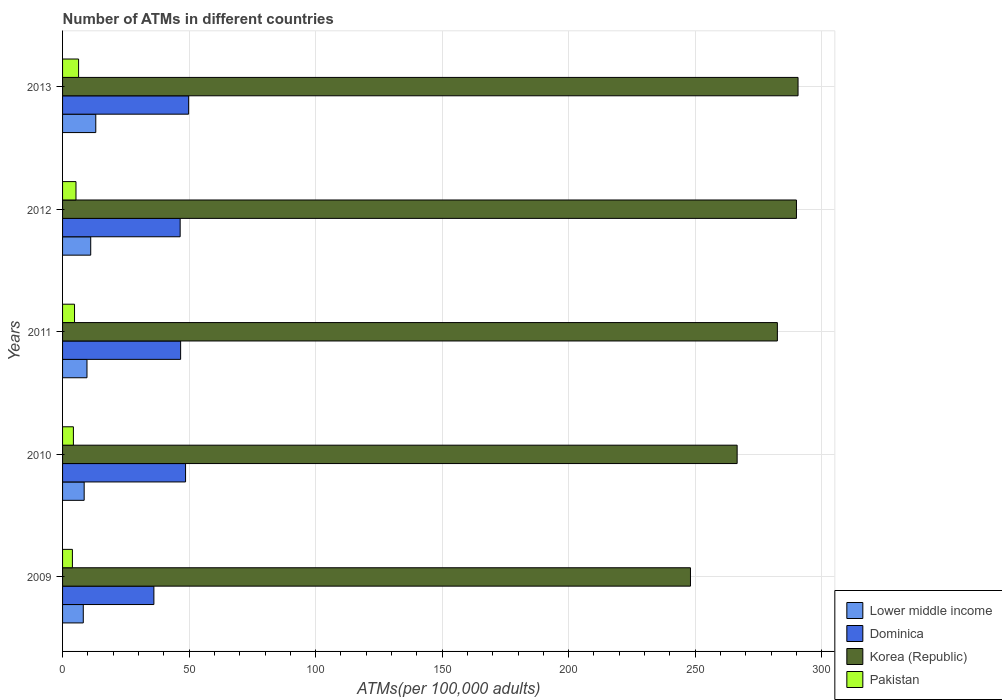How many different coloured bars are there?
Your answer should be compact. 4. Are the number of bars on each tick of the Y-axis equal?
Offer a very short reply. Yes. How many bars are there on the 2nd tick from the bottom?
Keep it short and to the point. 4. In how many cases, is the number of bars for a given year not equal to the number of legend labels?
Keep it short and to the point. 0. What is the number of ATMs in Pakistan in 2009?
Keep it short and to the point. 3.89. Across all years, what is the maximum number of ATMs in Dominica?
Your answer should be compact. 49.82. Across all years, what is the minimum number of ATMs in Lower middle income?
Your answer should be compact. 8.19. In which year was the number of ATMs in Pakistan minimum?
Ensure brevity in your answer.  2009. What is the total number of ATMs in Korea (Republic) in the graph?
Your answer should be very brief. 1377.92. What is the difference between the number of ATMs in Dominica in 2009 and that in 2013?
Offer a terse response. -13.73. What is the difference between the number of ATMs in Pakistan in 2010 and the number of ATMs in Korea (Republic) in 2012?
Keep it short and to the point. -285.75. What is the average number of ATMs in Korea (Republic) per year?
Your answer should be very brief. 275.58. In the year 2012, what is the difference between the number of ATMs in Korea (Republic) and number of ATMs in Dominica?
Provide a succinct answer. 243.56. What is the ratio of the number of ATMs in Dominica in 2011 to that in 2013?
Your answer should be very brief. 0.94. What is the difference between the highest and the second highest number of ATMs in Lower middle income?
Give a very brief answer. 2. What is the difference between the highest and the lowest number of ATMs in Korea (Republic)?
Keep it short and to the point. 42.51. What does the 4th bar from the top in 2012 represents?
Provide a succinct answer. Lower middle income. What does the 4th bar from the bottom in 2010 represents?
Keep it short and to the point. Pakistan. Is it the case that in every year, the sum of the number of ATMs in Korea (Republic) and number of ATMs in Lower middle income is greater than the number of ATMs in Dominica?
Provide a short and direct response. Yes. Are all the bars in the graph horizontal?
Make the answer very short. Yes. Does the graph contain any zero values?
Your response must be concise. No. Where does the legend appear in the graph?
Keep it short and to the point. Bottom right. What is the title of the graph?
Provide a short and direct response. Number of ATMs in different countries. What is the label or title of the X-axis?
Provide a short and direct response. ATMs(per 100,0 adults). What is the ATMs(per 100,000 adults) in Lower middle income in 2009?
Your answer should be compact. 8.19. What is the ATMs(per 100,000 adults) in Dominica in 2009?
Provide a succinct answer. 36.09. What is the ATMs(per 100,000 adults) of Korea (Republic) in 2009?
Provide a succinct answer. 248.15. What is the ATMs(per 100,000 adults) of Pakistan in 2009?
Your answer should be very brief. 3.89. What is the ATMs(per 100,000 adults) in Lower middle income in 2010?
Your answer should be compact. 8.54. What is the ATMs(per 100,000 adults) in Dominica in 2010?
Your answer should be very brief. 48.61. What is the ATMs(per 100,000 adults) of Korea (Republic) in 2010?
Provide a succinct answer. 266.59. What is the ATMs(per 100,000 adults) in Pakistan in 2010?
Ensure brevity in your answer.  4.28. What is the ATMs(per 100,000 adults) of Lower middle income in 2011?
Ensure brevity in your answer.  9.65. What is the ATMs(per 100,000 adults) in Dominica in 2011?
Your response must be concise. 46.65. What is the ATMs(per 100,000 adults) in Korea (Republic) in 2011?
Offer a terse response. 282.49. What is the ATMs(per 100,000 adults) in Pakistan in 2011?
Offer a very short reply. 4.73. What is the ATMs(per 100,000 adults) in Lower middle income in 2012?
Offer a terse response. 11.13. What is the ATMs(per 100,000 adults) in Dominica in 2012?
Your response must be concise. 46.47. What is the ATMs(per 100,000 adults) in Korea (Republic) in 2012?
Provide a succinct answer. 290.03. What is the ATMs(per 100,000 adults) of Pakistan in 2012?
Your answer should be compact. 5.31. What is the ATMs(per 100,000 adults) of Lower middle income in 2013?
Your response must be concise. 13.13. What is the ATMs(per 100,000 adults) in Dominica in 2013?
Ensure brevity in your answer.  49.82. What is the ATMs(per 100,000 adults) of Korea (Republic) in 2013?
Your answer should be compact. 290.66. What is the ATMs(per 100,000 adults) of Pakistan in 2013?
Keep it short and to the point. 6.33. Across all years, what is the maximum ATMs(per 100,000 adults) in Lower middle income?
Ensure brevity in your answer.  13.13. Across all years, what is the maximum ATMs(per 100,000 adults) of Dominica?
Your answer should be very brief. 49.82. Across all years, what is the maximum ATMs(per 100,000 adults) in Korea (Republic)?
Provide a succinct answer. 290.66. Across all years, what is the maximum ATMs(per 100,000 adults) of Pakistan?
Make the answer very short. 6.33. Across all years, what is the minimum ATMs(per 100,000 adults) of Lower middle income?
Ensure brevity in your answer.  8.19. Across all years, what is the minimum ATMs(per 100,000 adults) in Dominica?
Your response must be concise. 36.09. Across all years, what is the minimum ATMs(per 100,000 adults) of Korea (Republic)?
Offer a terse response. 248.15. Across all years, what is the minimum ATMs(per 100,000 adults) in Pakistan?
Provide a succinct answer. 3.89. What is the total ATMs(per 100,000 adults) in Lower middle income in the graph?
Offer a very short reply. 50.63. What is the total ATMs(per 100,000 adults) in Dominica in the graph?
Provide a succinct answer. 227.65. What is the total ATMs(per 100,000 adults) in Korea (Republic) in the graph?
Ensure brevity in your answer.  1377.92. What is the total ATMs(per 100,000 adults) of Pakistan in the graph?
Provide a short and direct response. 24.54. What is the difference between the ATMs(per 100,000 adults) in Lower middle income in 2009 and that in 2010?
Provide a short and direct response. -0.35. What is the difference between the ATMs(per 100,000 adults) in Dominica in 2009 and that in 2010?
Your answer should be very brief. -12.52. What is the difference between the ATMs(per 100,000 adults) in Korea (Republic) in 2009 and that in 2010?
Ensure brevity in your answer.  -18.45. What is the difference between the ATMs(per 100,000 adults) in Pakistan in 2009 and that in 2010?
Your answer should be very brief. -0.39. What is the difference between the ATMs(per 100,000 adults) in Lower middle income in 2009 and that in 2011?
Keep it short and to the point. -1.46. What is the difference between the ATMs(per 100,000 adults) in Dominica in 2009 and that in 2011?
Your answer should be compact. -10.56. What is the difference between the ATMs(per 100,000 adults) of Korea (Republic) in 2009 and that in 2011?
Make the answer very short. -34.34. What is the difference between the ATMs(per 100,000 adults) in Pakistan in 2009 and that in 2011?
Your answer should be compact. -0.84. What is the difference between the ATMs(per 100,000 adults) in Lower middle income in 2009 and that in 2012?
Your response must be concise. -2.94. What is the difference between the ATMs(per 100,000 adults) of Dominica in 2009 and that in 2012?
Provide a succinct answer. -10.38. What is the difference between the ATMs(per 100,000 adults) in Korea (Republic) in 2009 and that in 2012?
Ensure brevity in your answer.  -41.88. What is the difference between the ATMs(per 100,000 adults) in Pakistan in 2009 and that in 2012?
Give a very brief answer. -1.41. What is the difference between the ATMs(per 100,000 adults) in Lower middle income in 2009 and that in 2013?
Your response must be concise. -4.94. What is the difference between the ATMs(per 100,000 adults) of Dominica in 2009 and that in 2013?
Offer a terse response. -13.73. What is the difference between the ATMs(per 100,000 adults) in Korea (Republic) in 2009 and that in 2013?
Provide a succinct answer. -42.51. What is the difference between the ATMs(per 100,000 adults) in Pakistan in 2009 and that in 2013?
Offer a terse response. -2.44. What is the difference between the ATMs(per 100,000 adults) in Lower middle income in 2010 and that in 2011?
Offer a terse response. -1.11. What is the difference between the ATMs(per 100,000 adults) of Dominica in 2010 and that in 2011?
Ensure brevity in your answer.  1.95. What is the difference between the ATMs(per 100,000 adults) of Korea (Republic) in 2010 and that in 2011?
Give a very brief answer. -15.9. What is the difference between the ATMs(per 100,000 adults) in Pakistan in 2010 and that in 2011?
Your answer should be compact. -0.45. What is the difference between the ATMs(per 100,000 adults) in Lower middle income in 2010 and that in 2012?
Make the answer very short. -2.59. What is the difference between the ATMs(per 100,000 adults) in Dominica in 2010 and that in 2012?
Offer a terse response. 2.14. What is the difference between the ATMs(per 100,000 adults) of Korea (Republic) in 2010 and that in 2012?
Make the answer very short. -23.44. What is the difference between the ATMs(per 100,000 adults) in Pakistan in 2010 and that in 2012?
Your response must be concise. -1.02. What is the difference between the ATMs(per 100,000 adults) of Lower middle income in 2010 and that in 2013?
Provide a succinct answer. -4.59. What is the difference between the ATMs(per 100,000 adults) in Dominica in 2010 and that in 2013?
Provide a short and direct response. -1.22. What is the difference between the ATMs(per 100,000 adults) of Korea (Republic) in 2010 and that in 2013?
Offer a very short reply. -24.07. What is the difference between the ATMs(per 100,000 adults) of Pakistan in 2010 and that in 2013?
Provide a succinct answer. -2.05. What is the difference between the ATMs(per 100,000 adults) of Lower middle income in 2011 and that in 2012?
Your answer should be compact. -1.48. What is the difference between the ATMs(per 100,000 adults) of Dominica in 2011 and that in 2012?
Make the answer very short. 0.18. What is the difference between the ATMs(per 100,000 adults) of Korea (Republic) in 2011 and that in 2012?
Your response must be concise. -7.54. What is the difference between the ATMs(per 100,000 adults) of Pakistan in 2011 and that in 2012?
Keep it short and to the point. -0.58. What is the difference between the ATMs(per 100,000 adults) in Lower middle income in 2011 and that in 2013?
Keep it short and to the point. -3.47. What is the difference between the ATMs(per 100,000 adults) of Dominica in 2011 and that in 2013?
Give a very brief answer. -3.17. What is the difference between the ATMs(per 100,000 adults) of Korea (Republic) in 2011 and that in 2013?
Your response must be concise. -8.17. What is the difference between the ATMs(per 100,000 adults) of Pakistan in 2011 and that in 2013?
Your answer should be very brief. -1.61. What is the difference between the ATMs(per 100,000 adults) of Lower middle income in 2012 and that in 2013?
Keep it short and to the point. -2. What is the difference between the ATMs(per 100,000 adults) in Dominica in 2012 and that in 2013?
Keep it short and to the point. -3.35. What is the difference between the ATMs(per 100,000 adults) in Korea (Republic) in 2012 and that in 2013?
Your response must be concise. -0.63. What is the difference between the ATMs(per 100,000 adults) of Pakistan in 2012 and that in 2013?
Keep it short and to the point. -1.03. What is the difference between the ATMs(per 100,000 adults) in Lower middle income in 2009 and the ATMs(per 100,000 adults) in Dominica in 2010?
Give a very brief answer. -40.42. What is the difference between the ATMs(per 100,000 adults) of Lower middle income in 2009 and the ATMs(per 100,000 adults) of Korea (Republic) in 2010?
Your response must be concise. -258.4. What is the difference between the ATMs(per 100,000 adults) of Lower middle income in 2009 and the ATMs(per 100,000 adults) of Pakistan in 2010?
Give a very brief answer. 3.91. What is the difference between the ATMs(per 100,000 adults) of Dominica in 2009 and the ATMs(per 100,000 adults) of Korea (Republic) in 2010?
Provide a short and direct response. -230.5. What is the difference between the ATMs(per 100,000 adults) in Dominica in 2009 and the ATMs(per 100,000 adults) in Pakistan in 2010?
Keep it short and to the point. 31.81. What is the difference between the ATMs(per 100,000 adults) of Korea (Republic) in 2009 and the ATMs(per 100,000 adults) of Pakistan in 2010?
Provide a succinct answer. 243.87. What is the difference between the ATMs(per 100,000 adults) in Lower middle income in 2009 and the ATMs(per 100,000 adults) in Dominica in 2011?
Offer a very short reply. -38.47. What is the difference between the ATMs(per 100,000 adults) of Lower middle income in 2009 and the ATMs(per 100,000 adults) of Korea (Republic) in 2011?
Keep it short and to the point. -274.3. What is the difference between the ATMs(per 100,000 adults) of Lower middle income in 2009 and the ATMs(per 100,000 adults) of Pakistan in 2011?
Your answer should be very brief. 3.46. What is the difference between the ATMs(per 100,000 adults) of Dominica in 2009 and the ATMs(per 100,000 adults) of Korea (Republic) in 2011?
Your response must be concise. -246.4. What is the difference between the ATMs(per 100,000 adults) in Dominica in 2009 and the ATMs(per 100,000 adults) in Pakistan in 2011?
Give a very brief answer. 31.37. What is the difference between the ATMs(per 100,000 adults) in Korea (Republic) in 2009 and the ATMs(per 100,000 adults) in Pakistan in 2011?
Your response must be concise. 243.42. What is the difference between the ATMs(per 100,000 adults) in Lower middle income in 2009 and the ATMs(per 100,000 adults) in Dominica in 2012?
Offer a terse response. -38.28. What is the difference between the ATMs(per 100,000 adults) of Lower middle income in 2009 and the ATMs(per 100,000 adults) of Korea (Republic) in 2012?
Give a very brief answer. -281.84. What is the difference between the ATMs(per 100,000 adults) in Lower middle income in 2009 and the ATMs(per 100,000 adults) in Pakistan in 2012?
Make the answer very short. 2.88. What is the difference between the ATMs(per 100,000 adults) in Dominica in 2009 and the ATMs(per 100,000 adults) in Korea (Republic) in 2012?
Offer a terse response. -253.94. What is the difference between the ATMs(per 100,000 adults) of Dominica in 2009 and the ATMs(per 100,000 adults) of Pakistan in 2012?
Provide a succinct answer. 30.79. What is the difference between the ATMs(per 100,000 adults) of Korea (Republic) in 2009 and the ATMs(per 100,000 adults) of Pakistan in 2012?
Give a very brief answer. 242.84. What is the difference between the ATMs(per 100,000 adults) of Lower middle income in 2009 and the ATMs(per 100,000 adults) of Dominica in 2013?
Your answer should be compact. -41.63. What is the difference between the ATMs(per 100,000 adults) of Lower middle income in 2009 and the ATMs(per 100,000 adults) of Korea (Republic) in 2013?
Keep it short and to the point. -282.47. What is the difference between the ATMs(per 100,000 adults) of Lower middle income in 2009 and the ATMs(per 100,000 adults) of Pakistan in 2013?
Your response must be concise. 1.86. What is the difference between the ATMs(per 100,000 adults) in Dominica in 2009 and the ATMs(per 100,000 adults) in Korea (Republic) in 2013?
Ensure brevity in your answer.  -254.57. What is the difference between the ATMs(per 100,000 adults) of Dominica in 2009 and the ATMs(per 100,000 adults) of Pakistan in 2013?
Give a very brief answer. 29.76. What is the difference between the ATMs(per 100,000 adults) of Korea (Republic) in 2009 and the ATMs(per 100,000 adults) of Pakistan in 2013?
Provide a succinct answer. 241.81. What is the difference between the ATMs(per 100,000 adults) in Lower middle income in 2010 and the ATMs(per 100,000 adults) in Dominica in 2011?
Make the answer very short. -38.12. What is the difference between the ATMs(per 100,000 adults) in Lower middle income in 2010 and the ATMs(per 100,000 adults) in Korea (Republic) in 2011?
Keep it short and to the point. -273.95. What is the difference between the ATMs(per 100,000 adults) of Lower middle income in 2010 and the ATMs(per 100,000 adults) of Pakistan in 2011?
Ensure brevity in your answer.  3.81. What is the difference between the ATMs(per 100,000 adults) of Dominica in 2010 and the ATMs(per 100,000 adults) of Korea (Republic) in 2011?
Provide a succinct answer. -233.88. What is the difference between the ATMs(per 100,000 adults) in Dominica in 2010 and the ATMs(per 100,000 adults) in Pakistan in 2011?
Offer a terse response. 43.88. What is the difference between the ATMs(per 100,000 adults) in Korea (Republic) in 2010 and the ATMs(per 100,000 adults) in Pakistan in 2011?
Your answer should be very brief. 261.87. What is the difference between the ATMs(per 100,000 adults) of Lower middle income in 2010 and the ATMs(per 100,000 adults) of Dominica in 2012?
Give a very brief answer. -37.93. What is the difference between the ATMs(per 100,000 adults) of Lower middle income in 2010 and the ATMs(per 100,000 adults) of Korea (Republic) in 2012?
Offer a terse response. -281.49. What is the difference between the ATMs(per 100,000 adults) of Lower middle income in 2010 and the ATMs(per 100,000 adults) of Pakistan in 2012?
Your answer should be very brief. 3.23. What is the difference between the ATMs(per 100,000 adults) in Dominica in 2010 and the ATMs(per 100,000 adults) in Korea (Republic) in 2012?
Your response must be concise. -241.42. What is the difference between the ATMs(per 100,000 adults) of Dominica in 2010 and the ATMs(per 100,000 adults) of Pakistan in 2012?
Your answer should be very brief. 43.3. What is the difference between the ATMs(per 100,000 adults) in Korea (Republic) in 2010 and the ATMs(per 100,000 adults) in Pakistan in 2012?
Your response must be concise. 261.29. What is the difference between the ATMs(per 100,000 adults) in Lower middle income in 2010 and the ATMs(per 100,000 adults) in Dominica in 2013?
Your response must be concise. -41.28. What is the difference between the ATMs(per 100,000 adults) in Lower middle income in 2010 and the ATMs(per 100,000 adults) in Korea (Republic) in 2013?
Give a very brief answer. -282.12. What is the difference between the ATMs(per 100,000 adults) of Lower middle income in 2010 and the ATMs(per 100,000 adults) of Pakistan in 2013?
Your answer should be very brief. 2.21. What is the difference between the ATMs(per 100,000 adults) in Dominica in 2010 and the ATMs(per 100,000 adults) in Korea (Republic) in 2013?
Provide a short and direct response. -242.05. What is the difference between the ATMs(per 100,000 adults) of Dominica in 2010 and the ATMs(per 100,000 adults) of Pakistan in 2013?
Provide a succinct answer. 42.27. What is the difference between the ATMs(per 100,000 adults) of Korea (Republic) in 2010 and the ATMs(per 100,000 adults) of Pakistan in 2013?
Provide a short and direct response. 260.26. What is the difference between the ATMs(per 100,000 adults) in Lower middle income in 2011 and the ATMs(per 100,000 adults) in Dominica in 2012?
Offer a very short reply. -36.82. What is the difference between the ATMs(per 100,000 adults) of Lower middle income in 2011 and the ATMs(per 100,000 adults) of Korea (Republic) in 2012?
Provide a short and direct response. -280.38. What is the difference between the ATMs(per 100,000 adults) in Lower middle income in 2011 and the ATMs(per 100,000 adults) in Pakistan in 2012?
Offer a terse response. 4.35. What is the difference between the ATMs(per 100,000 adults) of Dominica in 2011 and the ATMs(per 100,000 adults) of Korea (Republic) in 2012?
Make the answer very short. -243.38. What is the difference between the ATMs(per 100,000 adults) of Dominica in 2011 and the ATMs(per 100,000 adults) of Pakistan in 2012?
Offer a very short reply. 41.35. What is the difference between the ATMs(per 100,000 adults) in Korea (Republic) in 2011 and the ATMs(per 100,000 adults) in Pakistan in 2012?
Your answer should be very brief. 277.19. What is the difference between the ATMs(per 100,000 adults) in Lower middle income in 2011 and the ATMs(per 100,000 adults) in Dominica in 2013?
Offer a very short reply. -40.17. What is the difference between the ATMs(per 100,000 adults) in Lower middle income in 2011 and the ATMs(per 100,000 adults) in Korea (Republic) in 2013?
Offer a very short reply. -281.01. What is the difference between the ATMs(per 100,000 adults) in Lower middle income in 2011 and the ATMs(per 100,000 adults) in Pakistan in 2013?
Provide a short and direct response. 3.32. What is the difference between the ATMs(per 100,000 adults) in Dominica in 2011 and the ATMs(per 100,000 adults) in Korea (Republic) in 2013?
Offer a terse response. -244.01. What is the difference between the ATMs(per 100,000 adults) in Dominica in 2011 and the ATMs(per 100,000 adults) in Pakistan in 2013?
Your answer should be compact. 40.32. What is the difference between the ATMs(per 100,000 adults) of Korea (Republic) in 2011 and the ATMs(per 100,000 adults) of Pakistan in 2013?
Provide a short and direct response. 276.16. What is the difference between the ATMs(per 100,000 adults) in Lower middle income in 2012 and the ATMs(per 100,000 adults) in Dominica in 2013?
Your answer should be very brief. -38.69. What is the difference between the ATMs(per 100,000 adults) of Lower middle income in 2012 and the ATMs(per 100,000 adults) of Korea (Republic) in 2013?
Provide a short and direct response. -279.53. What is the difference between the ATMs(per 100,000 adults) of Lower middle income in 2012 and the ATMs(per 100,000 adults) of Pakistan in 2013?
Your response must be concise. 4.8. What is the difference between the ATMs(per 100,000 adults) of Dominica in 2012 and the ATMs(per 100,000 adults) of Korea (Republic) in 2013?
Provide a succinct answer. -244.19. What is the difference between the ATMs(per 100,000 adults) of Dominica in 2012 and the ATMs(per 100,000 adults) of Pakistan in 2013?
Your answer should be compact. 40.14. What is the difference between the ATMs(per 100,000 adults) in Korea (Republic) in 2012 and the ATMs(per 100,000 adults) in Pakistan in 2013?
Ensure brevity in your answer.  283.7. What is the average ATMs(per 100,000 adults) in Lower middle income per year?
Your answer should be compact. 10.13. What is the average ATMs(per 100,000 adults) of Dominica per year?
Offer a terse response. 45.53. What is the average ATMs(per 100,000 adults) in Korea (Republic) per year?
Your answer should be very brief. 275.58. What is the average ATMs(per 100,000 adults) in Pakistan per year?
Give a very brief answer. 4.91. In the year 2009, what is the difference between the ATMs(per 100,000 adults) in Lower middle income and ATMs(per 100,000 adults) in Dominica?
Make the answer very short. -27.9. In the year 2009, what is the difference between the ATMs(per 100,000 adults) in Lower middle income and ATMs(per 100,000 adults) in Korea (Republic)?
Your response must be concise. -239.96. In the year 2009, what is the difference between the ATMs(per 100,000 adults) of Lower middle income and ATMs(per 100,000 adults) of Pakistan?
Keep it short and to the point. 4.3. In the year 2009, what is the difference between the ATMs(per 100,000 adults) in Dominica and ATMs(per 100,000 adults) in Korea (Republic)?
Offer a terse response. -212.05. In the year 2009, what is the difference between the ATMs(per 100,000 adults) of Dominica and ATMs(per 100,000 adults) of Pakistan?
Ensure brevity in your answer.  32.2. In the year 2009, what is the difference between the ATMs(per 100,000 adults) in Korea (Republic) and ATMs(per 100,000 adults) in Pakistan?
Offer a very short reply. 244.26. In the year 2010, what is the difference between the ATMs(per 100,000 adults) of Lower middle income and ATMs(per 100,000 adults) of Dominica?
Provide a short and direct response. -40.07. In the year 2010, what is the difference between the ATMs(per 100,000 adults) in Lower middle income and ATMs(per 100,000 adults) in Korea (Republic)?
Provide a succinct answer. -258.05. In the year 2010, what is the difference between the ATMs(per 100,000 adults) of Lower middle income and ATMs(per 100,000 adults) of Pakistan?
Your answer should be very brief. 4.26. In the year 2010, what is the difference between the ATMs(per 100,000 adults) in Dominica and ATMs(per 100,000 adults) in Korea (Republic)?
Make the answer very short. -217.98. In the year 2010, what is the difference between the ATMs(per 100,000 adults) in Dominica and ATMs(per 100,000 adults) in Pakistan?
Ensure brevity in your answer.  44.33. In the year 2010, what is the difference between the ATMs(per 100,000 adults) in Korea (Republic) and ATMs(per 100,000 adults) in Pakistan?
Offer a very short reply. 262.31. In the year 2011, what is the difference between the ATMs(per 100,000 adults) in Lower middle income and ATMs(per 100,000 adults) in Dominica?
Your response must be concise. -37. In the year 2011, what is the difference between the ATMs(per 100,000 adults) of Lower middle income and ATMs(per 100,000 adults) of Korea (Republic)?
Provide a short and direct response. -272.84. In the year 2011, what is the difference between the ATMs(per 100,000 adults) of Lower middle income and ATMs(per 100,000 adults) of Pakistan?
Make the answer very short. 4.92. In the year 2011, what is the difference between the ATMs(per 100,000 adults) of Dominica and ATMs(per 100,000 adults) of Korea (Republic)?
Your answer should be very brief. -235.84. In the year 2011, what is the difference between the ATMs(per 100,000 adults) in Dominica and ATMs(per 100,000 adults) in Pakistan?
Give a very brief answer. 41.93. In the year 2011, what is the difference between the ATMs(per 100,000 adults) in Korea (Republic) and ATMs(per 100,000 adults) in Pakistan?
Provide a short and direct response. 277.76. In the year 2012, what is the difference between the ATMs(per 100,000 adults) of Lower middle income and ATMs(per 100,000 adults) of Dominica?
Keep it short and to the point. -35.34. In the year 2012, what is the difference between the ATMs(per 100,000 adults) in Lower middle income and ATMs(per 100,000 adults) in Korea (Republic)?
Provide a succinct answer. -278.9. In the year 2012, what is the difference between the ATMs(per 100,000 adults) in Lower middle income and ATMs(per 100,000 adults) in Pakistan?
Keep it short and to the point. 5.82. In the year 2012, what is the difference between the ATMs(per 100,000 adults) in Dominica and ATMs(per 100,000 adults) in Korea (Republic)?
Provide a succinct answer. -243.56. In the year 2012, what is the difference between the ATMs(per 100,000 adults) of Dominica and ATMs(per 100,000 adults) of Pakistan?
Ensure brevity in your answer.  41.17. In the year 2012, what is the difference between the ATMs(per 100,000 adults) in Korea (Republic) and ATMs(per 100,000 adults) in Pakistan?
Provide a succinct answer. 284.73. In the year 2013, what is the difference between the ATMs(per 100,000 adults) of Lower middle income and ATMs(per 100,000 adults) of Dominica?
Ensure brevity in your answer.  -36.7. In the year 2013, what is the difference between the ATMs(per 100,000 adults) of Lower middle income and ATMs(per 100,000 adults) of Korea (Republic)?
Make the answer very short. -277.54. In the year 2013, what is the difference between the ATMs(per 100,000 adults) in Lower middle income and ATMs(per 100,000 adults) in Pakistan?
Your answer should be very brief. 6.79. In the year 2013, what is the difference between the ATMs(per 100,000 adults) in Dominica and ATMs(per 100,000 adults) in Korea (Republic)?
Keep it short and to the point. -240.84. In the year 2013, what is the difference between the ATMs(per 100,000 adults) in Dominica and ATMs(per 100,000 adults) in Pakistan?
Your answer should be compact. 43.49. In the year 2013, what is the difference between the ATMs(per 100,000 adults) of Korea (Republic) and ATMs(per 100,000 adults) of Pakistan?
Keep it short and to the point. 284.33. What is the ratio of the ATMs(per 100,000 adults) of Lower middle income in 2009 to that in 2010?
Offer a terse response. 0.96. What is the ratio of the ATMs(per 100,000 adults) in Dominica in 2009 to that in 2010?
Your answer should be very brief. 0.74. What is the ratio of the ATMs(per 100,000 adults) in Korea (Republic) in 2009 to that in 2010?
Give a very brief answer. 0.93. What is the ratio of the ATMs(per 100,000 adults) of Pakistan in 2009 to that in 2010?
Give a very brief answer. 0.91. What is the ratio of the ATMs(per 100,000 adults) in Lower middle income in 2009 to that in 2011?
Provide a succinct answer. 0.85. What is the ratio of the ATMs(per 100,000 adults) of Dominica in 2009 to that in 2011?
Give a very brief answer. 0.77. What is the ratio of the ATMs(per 100,000 adults) of Korea (Republic) in 2009 to that in 2011?
Ensure brevity in your answer.  0.88. What is the ratio of the ATMs(per 100,000 adults) of Pakistan in 2009 to that in 2011?
Offer a terse response. 0.82. What is the ratio of the ATMs(per 100,000 adults) of Lower middle income in 2009 to that in 2012?
Provide a short and direct response. 0.74. What is the ratio of the ATMs(per 100,000 adults) in Dominica in 2009 to that in 2012?
Offer a terse response. 0.78. What is the ratio of the ATMs(per 100,000 adults) in Korea (Republic) in 2009 to that in 2012?
Offer a very short reply. 0.86. What is the ratio of the ATMs(per 100,000 adults) of Pakistan in 2009 to that in 2012?
Make the answer very short. 0.73. What is the ratio of the ATMs(per 100,000 adults) of Lower middle income in 2009 to that in 2013?
Make the answer very short. 0.62. What is the ratio of the ATMs(per 100,000 adults) in Dominica in 2009 to that in 2013?
Give a very brief answer. 0.72. What is the ratio of the ATMs(per 100,000 adults) in Korea (Republic) in 2009 to that in 2013?
Make the answer very short. 0.85. What is the ratio of the ATMs(per 100,000 adults) of Pakistan in 2009 to that in 2013?
Ensure brevity in your answer.  0.61. What is the ratio of the ATMs(per 100,000 adults) in Lower middle income in 2010 to that in 2011?
Make the answer very short. 0.88. What is the ratio of the ATMs(per 100,000 adults) of Dominica in 2010 to that in 2011?
Ensure brevity in your answer.  1.04. What is the ratio of the ATMs(per 100,000 adults) of Korea (Republic) in 2010 to that in 2011?
Provide a short and direct response. 0.94. What is the ratio of the ATMs(per 100,000 adults) in Pakistan in 2010 to that in 2011?
Ensure brevity in your answer.  0.91. What is the ratio of the ATMs(per 100,000 adults) in Lower middle income in 2010 to that in 2012?
Ensure brevity in your answer.  0.77. What is the ratio of the ATMs(per 100,000 adults) of Dominica in 2010 to that in 2012?
Give a very brief answer. 1.05. What is the ratio of the ATMs(per 100,000 adults) of Korea (Republic) in 2010 to that in 2012?
Offer a very short reply. 0.92. What is the ratio of the ATMs(per 100,000 adults) in Pakistan in 2010 to that in 2012?
Your answer should be compact. 0.81. What is the ratio of the ATMs(per 100,000 adults) in Lower middle income in 2010 to that in 2013?
Ensure brevity in your answer.  0.65. What is the ratio of the ATMs(per 100,000 adults) of Dominica in 2010 to that in 2013?
Offer a terse response. 0.98. What is the ratio of the ATMs(per 100,000 adults) in Korea (Republic) in 2010 to that in 2013?
Provide a short and direct response. 0.92. What is the ratio of the ATMs(per 100,000 adults) of Pakistan in 2010 to that in 2013?
Provide a succinct answer. 0.68. What is the ratio of the ATMs(per 100,000 adults) of Lower middle income in 2011 to that in 2012?
Provide a short and direct response. 0.87. What is the ratio of the ATMs(per 100,000 adults) of Pakistan in 2011 to that in 2012?
Your answer should be very brief. 0.89. What is the ratio of the ATMs(per 100,000 adults) of Lower middle income in 2011 to that in 2013?
Your answer should be very brief. 0.74. What is the ratio of the ATMs(per 100,000 adults) in Dominica in 2011 to that in 2013?
Make the answer very short. 0.94. What is the ratio of the ATMs(per 100,000 adults) in Korea (Republic) in 2011 to that in 2013?
Give a very brief answer. 0.97. What is the ratio of the ATMs(per 100,000 adults) in Pakistan in 2011 to that in 2013?
Your response must be concise. 0.75. What is the ratio of the ATMs(per 100,000 adults) of Lower middle income in 2012 to that in 2013?
Offer a very short reply. 0.85. What is the ratio of the ATMs(per 100,000 adults) of Dominica in 2012 to that in 2013?
Keep it short and to the point. 0.93. What is the ratio of the ATMs(per 100,000 adults) of Korea (Republic) in 2012 to that in 2013?
Keep it short and to the point. 1. What is the ratio of the ATMs(per 100,000 adults) of Pakistan in 2012 to that in 2013?
Make the answer very short. 0.84. What is the difference between the highest and the second highest ATMs(per 100,000 adults) in Lower middle income?
Ensure brevity in your answer.  2. What is the difference between the highest and the second highest ATMs(per 100,000 adults) in Dominica?
Make the answer very short. 1.22. What is the difference between the highest and the second highest ATMs(per 100,000 adults) of Korea (Republic)?
Offer a terse response. 0.63. What is the difference between the highest and the second highest ATMs(per 100,000 adults) of Pakistan?
Offer a terse response. 1.03. What is the difference between the highest and the lowest ATMs(per 100,000 adults) of Lower middle income?
Give a very brief answer. 4.94. What is the difference between the highest and the lowest ATMs(per 100,000 adults) of Dominica?
Provide a short and direct response. 13.73. What is the difference between the highest and the lowest ATMs(per 100,000 adults) in Korea (Republic)?
Offer a terse response. 42.51. What is the difference between the highest and the lowest ATMs(per 100,000 adults) of Pakistan?
Your answer should be very brief. 2.44. 